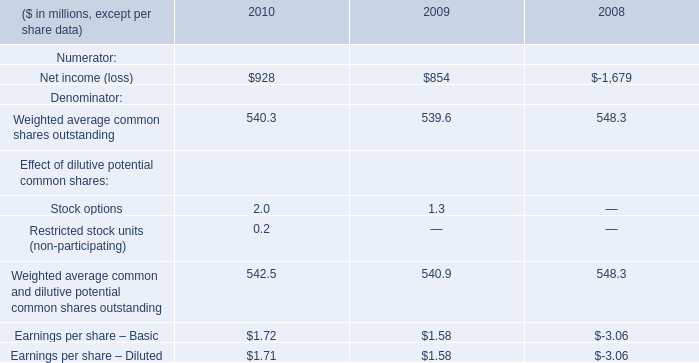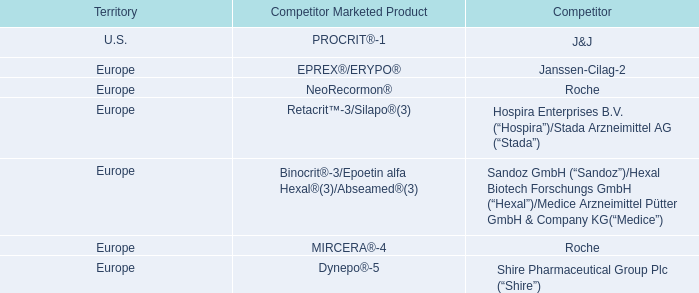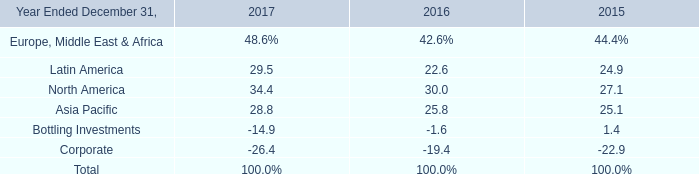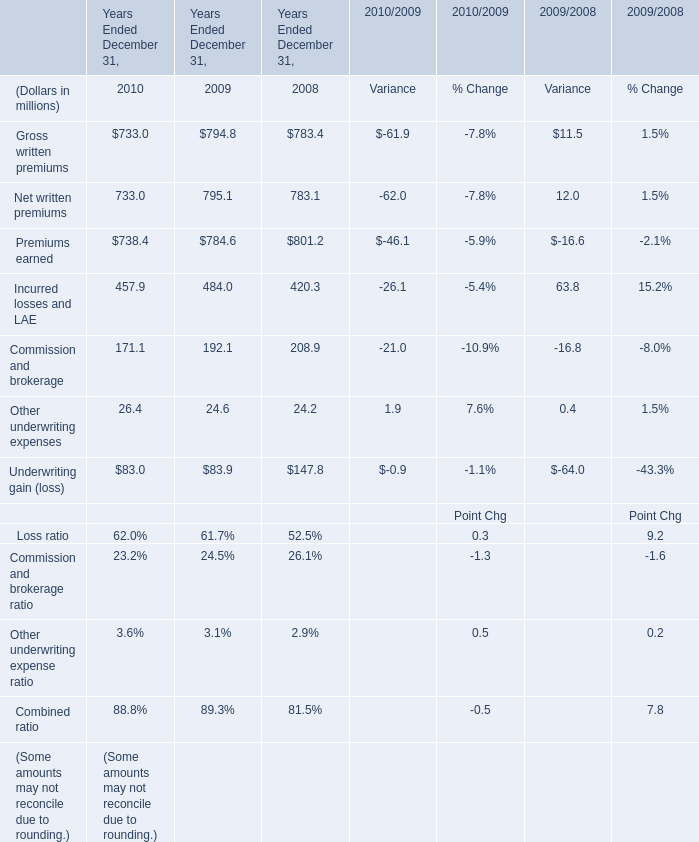What was the total amount of Years Ended December 31, in 2009? (in million) 
Computations: ((((((794.8 + 795.1) + 784.6) + 484) + 192.1) + 24.6) + 83.9)
Answer: 3159.1. 